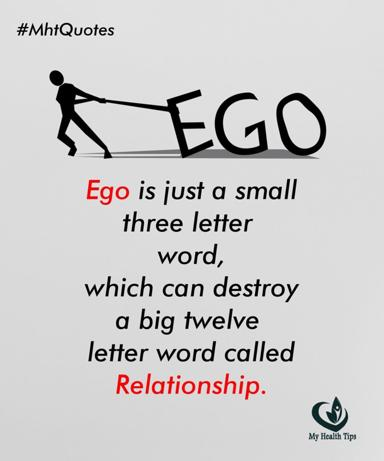What visual elements in the image underscore the impact of ego on relationships? The image uses a strong visual metaphor where a figure is shown dragging the word 'EGO', which is significantly larger and in bold, against the word 'Relationship'. The effort and strain in the posture of the figure vividly illustrate how ego can exert a demanding influence, threatening to overpower and damage the concept of relationship. 